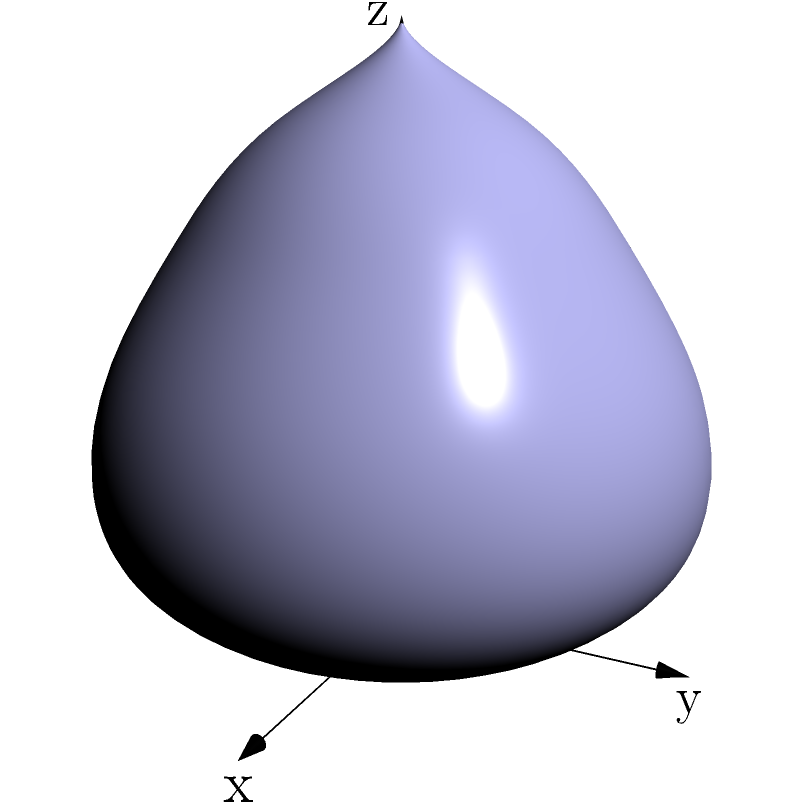As a costume design analyst, you're examining a fitted bodice with complex curves for a Broadway production. The surface area of the bodice can be modeled by the function $f(x,y) = (2\cos x \sin y, 2\sin x \sin y, (1+\cos y)e^{-y/3})$ where $0 \leq x \leq 2\pi$ and $0 \leq y \leq \pi$. Calculate the surface area of this bodice using a double integral. To calculate the surface area, we need to use the formula for surface area in vector form:

$$A = \int\int_R \left|\frac{\partial f}{\partial x} \times \frac{\partial f}{\partial y}\right| dxdy$$

Step 1: Calculate partial derivatives
$$\frac{\partial f}{\partial x} = (-2\sin x \sin y, 2\cos x \sin y, 0)$$
$$\frac{\partial f}{\partial y} = (2\cos x \cos y, 2\sin x \cos y, -\sin y e^{-y/3} - \frac{1}{3}(1+\cos y)e^{-y/3})$$

Step 2: Calculate the cross product
$$\frac{\partial f}{\partial x} \times \frac{\partial f}{\partial y} = $$
$$(2\cos x \sin y (\sin y e^{-y/3} + \frac{1}{3}(1+\cos y)e^{-y/3}),$$
$$2\sin x \sin y (\sin y e^{-y/3} + \frac{1}{3}(1+\cos y)e^{-y/3}),$$
$$4\sin^2 y)$$

Step 3: Calculate the magnitude of the cross product
$$\left|\frac{\partial f}{\partial x} \times \frac{\partial f}{\partial y}\right| = $$
$$\sqrt{4\sin^2 y (\sin y e^{-y/3} + \frac{1}{3}(1+\cos y)e^{-y/3})^2 + 16\sin^4 y}$$

Step 4: Set up the double integral
$$A = \int_0^{2\pi} \int_0^{\pi} \sqrt{4\sin^2 y (\sin y e^{-y/3} + \frac{1}{3}(1+\cos y)e^{-y/3})^2 + 16\sin^4 y} \, dy \, dx$$

Step 5: Simplify and evaluate
The integral is independent of x, so we can simplify:
$$A = 2\pi \int_0^{\pi} \sqrt{4\sin^2 y (\sin y e^{-y/3} + \frac{1}{3}(1+\cos y)e^{-y/3})^2 + 16\sin^4 y} \, dy$$

This integral cannot be evaluated analytically and requires numerical methods to solve.
Answer: $2\pi \int_0^{\pi} \sqrt{4\sin^2 y (\sin y e^{-y/3} + \frac{1}{3}(1+\cos y)e^{-y/3})^2 + 16\sin^4 y} \, dy$ 